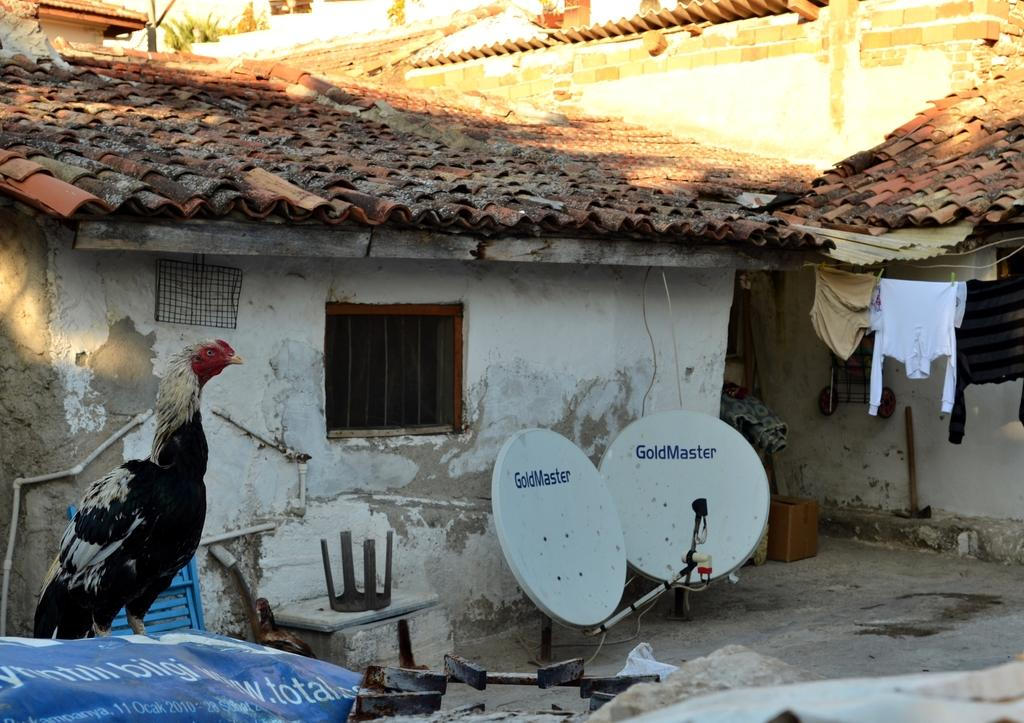What animal can be seen on the left side of the image? There is a hen on the left side of the image. What structures are located in the middle of the image? There are satellite dishes and houses in the middle of the image. What can be seen on the right side of the image? There are clothes on the right side of the image. Can you hear the baby crying in the image? A: There is no baby present in the image, so it is not possible to hear a baby crying. Is there a scarecrow standing among the clothes on the right side of the image? There is no scarecrow present in the image; only clothes are visible on the right side. 